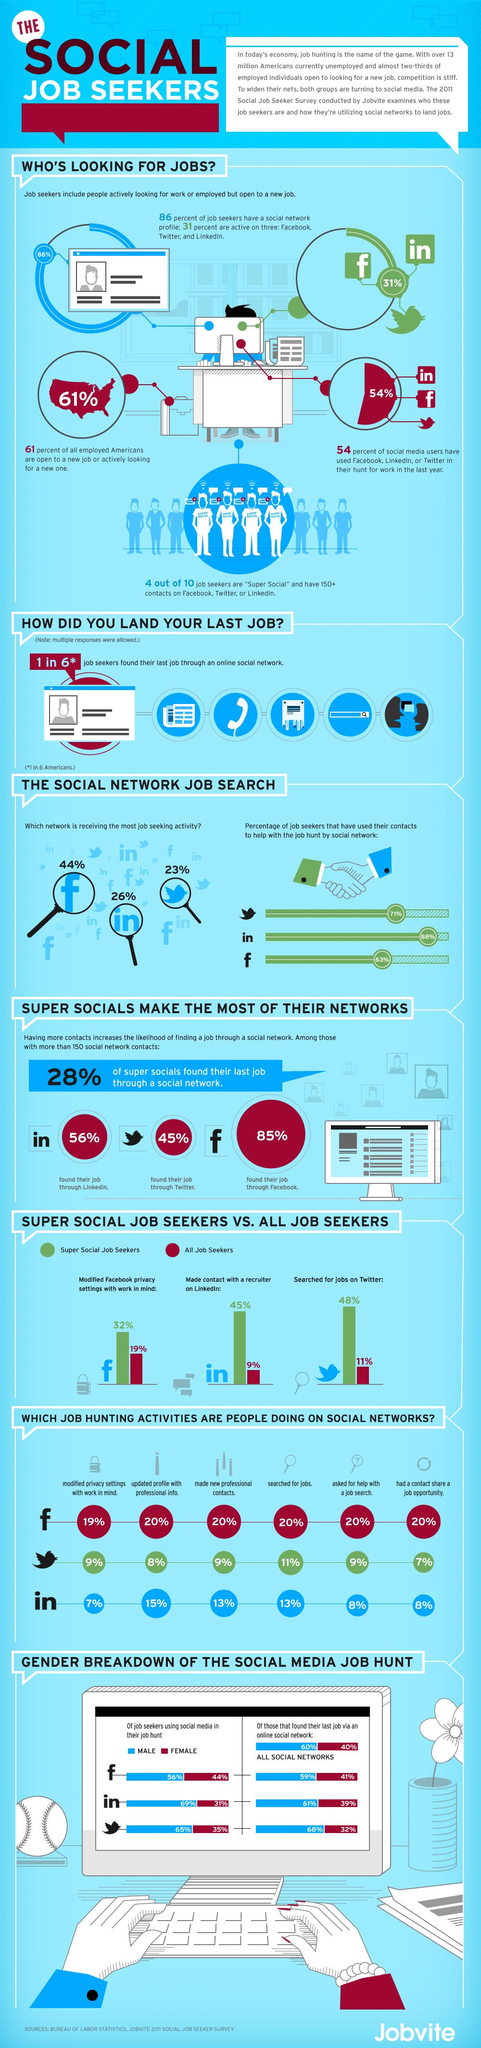Draw attention to some important aspects in this diagram. LinkedIn is the second most popular platform for job seekers to find employment opportunities. Twitter receives the least amount of job seeking activity among all networks. According to a recent survey, 56% of males are using Facebook in their job hunt. According to a study, Facebook was found to be 40% more effective than Twitter in helping individuals find employment. In a recent survey, it was found that 41% of females reported finding their last job through Facebook. 